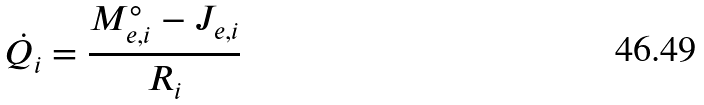Convert formula to latex. <formula><loc_0><loc_0><loc_500><loc_500>\dot { Q _ { i } } = \frac { M _ { e , i } ^ { \circ } - J _ { e , i } } { R _ { i } }</formula> 